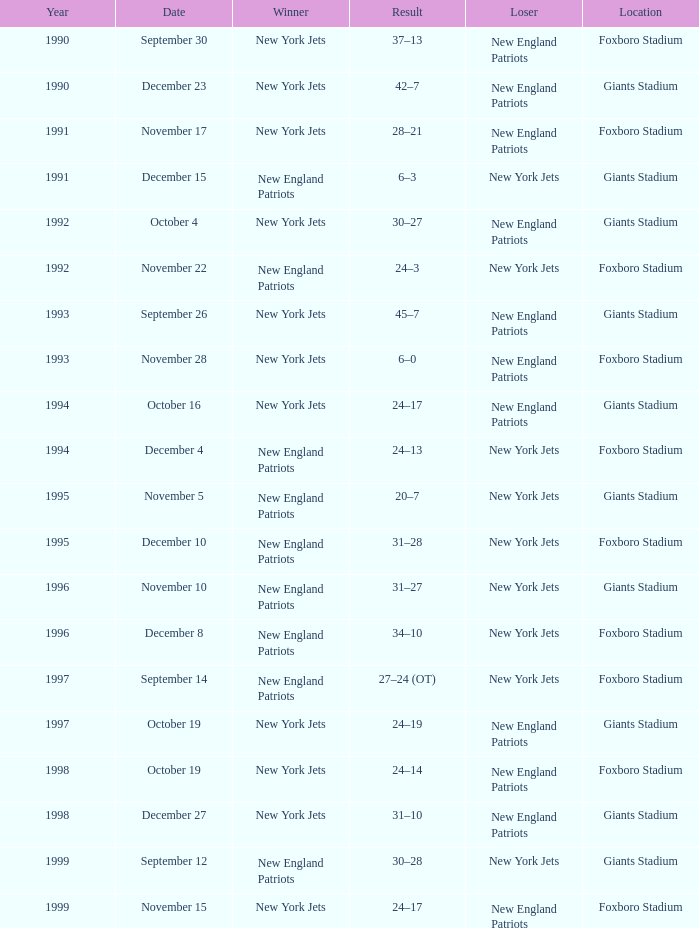What is the location when the new york jets lost earlier than 1997 and a Result of 31–28? Foxboro Stadium. 